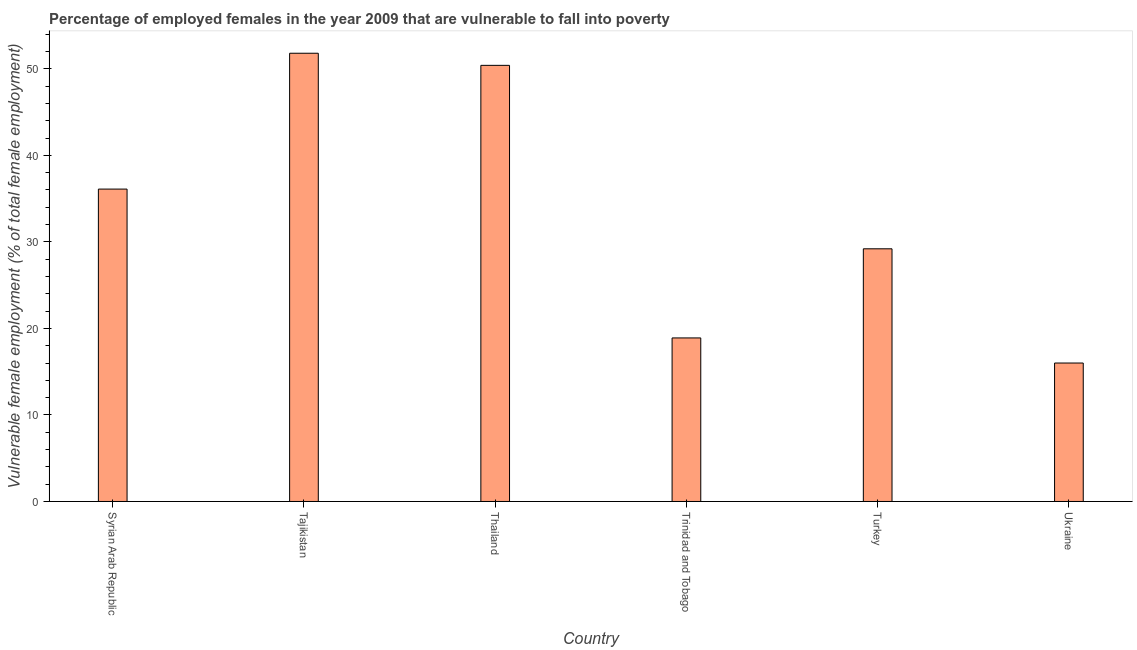Does the graph contain any zero values?
Give a very brief answer. No. Does the graph contain grids?
Offer a terse response. No. What is the title of the graph?
Offer a terse response. Percentage of employed females in the year 2009 that are vulnerable to fall into poverty. What is the label or title of the Y-axis?
Offer a terse response. Vulnerable female employment (% of total female employment). What is the percentage of employed females who are vulnerable to fall into poverty in Ukraine?
Make the answer very short. 16. Across all countries, what is the maximum percentage of employed females who are vulnerable to fall into poverty?
Provide a short and direct response. 51.8. In which country was the percentage of employed females who are vulnerable to fall into poverty maximum?
Your answer should be compact. Tajikistan. In which country was the percentage of employed females who are vulnerable to fall into poverty minimum?
Provide a short and direct response. Ukraine. What is the sum of the percentage of employed females who are vulnerable to fall into poverty?
Ensure brevity in your answer.  202.4. What is the difference between the percentage of employed females who are vulnerable to fall into poverty in Thailand and Ukraine?
Your answer should be compact. 34.4. What is the average percentage of employed females who are vulnerable to fall into poverty per country?
Provide a succinct answer. 33.73. What is the median percentage of employed females who are vulnerable to fall into poverty?
Offer a very short reply. 32.65. What is the ratio of the percentage of employed females who are vulnerable to fall into poverty in Turkey to that in Ukraine?
Ensure brevity in your answer.  1.82. What is the difference between the highest and the second highest percentage of employed females who are vulnerable to fall into poverty?
Keep it short and to the point. 1.4. Is the sum of the percentage of employed females who are vulnerable to fall into poverty in Syrian Arab Republic and Tajikistan greater than the maximum percentage of employed females who are vulnerable to fall into poverty across all countries?
Keep it short and to the point. Yes. What is the difference between the highest and the lowest percentage of employed females who are vulnerable to fall into poverty?
Make the answer very short. 35.8. How many bars are there?
Your answer should be very brief. 6. What is the difference between two consecutive major ticks on the Y-axis?
Offer a terse response. 10. Are the values on the major ticks of Y-axis written in scientific E-notation?
Offer a terse response. No. What is the Vulnerable female employment (% of total female employment) of Syrian Arab Republic?
Provide a succinct answer. 36.1. What is the Vulnerable female employment (% of total female employment) in Tajikistan?
Offer a very short reply. 51.8. What is the Vulnerable female employment (% of total female employment) of Thailand?
Make the answer very short. 50.4. What is the Vulnerable female employment (% of total female employment) in Trinidad and Tobago?
Ensure brevity in your answer.  18.9. What is the Vulnerable female employment (% of total female employment) of Turkey?
Make the answer very short. 29.2. What is the Vulnerable female employment (% of total female employment) of Ukraine?
Your response must be concise. 16. What is the difference between the Vulnerable female employment (% of total female employment) in Syrian Arab Republic and Tajikistan?
Give a very brief answer. -15.7. What is the difference between the Vulnerable female employment (% of total female employment) in Syrian Arab Republic and Thailand?
Your answer should be compact. -14.3. What is the difference between the Vulnerable female employment (% of total female employment) in Syrian Arab Republic and Ukraine?
Your answer should be compact. 20.1. What is the difference between the Vulnerable female employment (% of total female employment) in Tajikistan and Trinidad and Tobago?
Keep it short and to the point. 32.9. What is the difference between the Vulnerable female employment (% of total female employment) in Tajikistan and Turkey?
Offer a very short reply. 22.6. What is the difference between the Vulnerable female employment (% of total female employment) in Tajikistan and Ukraine?
Your response must be concise. 35.8. What is the difference between the Vulnerable female employment (% of total female employment) in Thailand and Trinidad and Tobago?
Provide a succinct answer. 31.5. What is the difference between the Vulnerable female employment (% of total female employment) in Thailand and Turkey?
Give a very brief answer. 21.2. What is the difference between the Vulnerable female employment (% of total female employment) in Thailand and Ukraine?
Your answer should be very brief. 34.4. What is the difference between the Vulnerable female employment (% of total female employment) in Trinidad and Tobago and Turkey?
Offer a terse response. -10.3. What is the ratio of the Vulnerable female employment (% of total female employment) in Syrian Arab Republic to that in Tajikistan?
Provide a succinct answer. 0.7. What is the ratio of the Vulnerable female employment (% of total female employment) in Syrian Arab Republic to that in Thailand?
Give a very brief answer. 0.72. What is the ratio of the Vulnerable female employment (% of total female employment) in Syrian Arab Republic to that in Trinidad and Tobago?
Provide a short and direct response. 1.91. What is the ratio of the Vulnerable female employment (% of total female employment) in Syrian Arab Republic to that in Turkey?
Your answer should be compact. 1.24. What is the ratio of the Vulnerable female employment (% of total female employment) in Syrian Arab Republic to that in Ukraine?
Provide a succinct answer. 2.26. What is the ratio of the Vulnerable female employment (% of total female employment) in Tajikistan to that in Thailand?
Ensure brevity in your answer.  1.03. What is the ratio of the Vulnerable female employment (% of total female employment) in Tajikistan to that in Trinidad and Tobago?
Your response must be concise. 2.74. What is the ratio of the Vulnerable female employment (% of total female employment) in Tajikistan to that in Turkey?
Ensure brevity in your answer.  1.77. What is the ratio of the Vulnerable female employment (% of total female employment) in Tajikistan to that in Ukraine?
Keep it short and to the point. 3.24. What is the ratio of the Vulnerable female employment (% of total female employment) in Thailand to that in Trinidad and Tobago?
Make the answer very short. 2.67. What is the ratio of the Vulnerable female employment (% of total female employment) in Thailand to that in Turkey?
Your answer should be compact. 1.73. What is the ratio of the Vulnerable female employment (% of total female employment) in Thailand to that in Ukraine?
Ensure brevity in your answer.  3.15. What is the ratio of the Vulnerable female employment (% of total female employment) in Trinidad and Tobago to that in Turkey?
Ensure brevity in your answer.  0.65. What is the ratio of the Vulnerable female employment (% of total female employment) in Trinidad and Tobago to that in Ukraine?
Your answer should be very brief. 1.18. What is the ratio of the Vulnerable female employment (% of total female employment) in Turkey to that in Ukraine?
Your answer should be very brief. 1.82. 